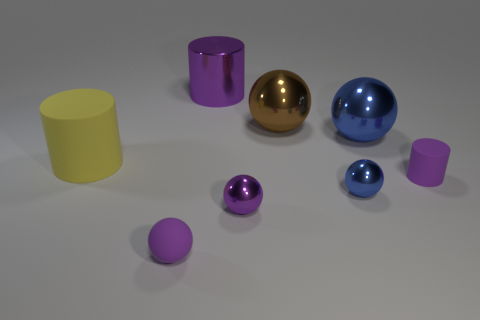Can you describe the lighting and atmosphere of the scene? The scene has soft, diffuse lighting that casts gentle shadows on the flat surface upon which the objects rest. The light source seems to be coming from above, and it accentuates the shiny texture of the metallic objects. There's a calm and clean atmosphere, as the background is neutral and doesn't distract from the primary subjects. 